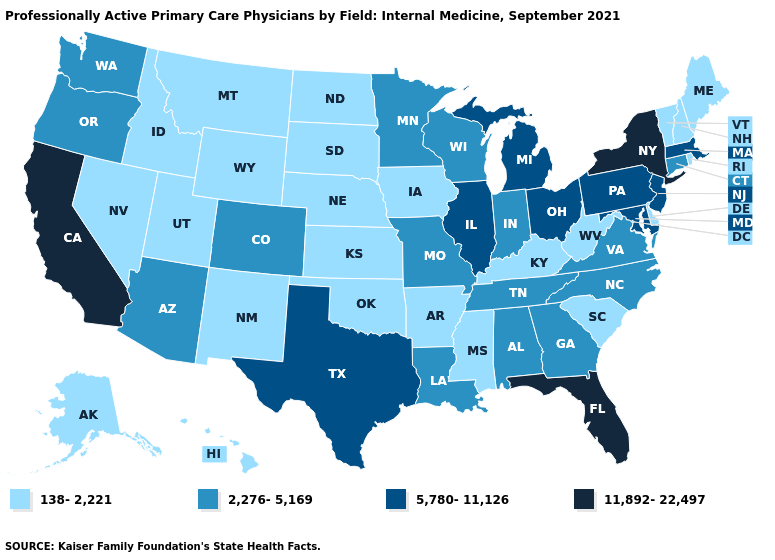Name the states that have a value in the range 5,780-11,126?
Concise answer only. Illinois, Maryland, Massachusetts, Michigan, New Jersey, Ohio, Pennsylvania, Texas. What is the value of Arkansas?
Concise answer only. 138-2,221. What is the value of Connecticut?
Write a very short answer. 2,276-5,169. What is the value of Massachusetts?
Answer briefly. 5,780-11,126. Does Kentucky have the lowest value in the South?
Concise answer only. Yes. How many symbols are there in the legend?
Keep it brief. 4. Name the states that have a value in the range 5,780-11,126?
Answer briefly. Illinois, Maryland, Massachusetts, Michigan, New Jersey, Ohio, Pennsylvania, Texas. What is the lowest value in the South?
Keep it brief. 138-2,221. Name the states that have a value in the range 138-2,221?
Answer briefly. Alaska, Arkansas, Delaware, Hawaii, Idaho, Iowa, Kansas, Kentucky, Maine, Mississippi, Montana, Nebraska, Nevada, New Hampshire, New Mexico, North Dakota, Oklahoma, Rhode Island, South Carolina, South Dakota, Utah, Vermont, West Virginia, Wyoming. What is the value of Vermont?
Give a very brief answer. 138-2,221. Which states hav the highest value in the West?
Keep it brief. California. What is the value of Minnesota?
Short answer required. 2,276-5,169. Which states hav the highest value in the MidWest?
Write a very short answer. Illinois, Michigan, Ohio. Name the states that have a value in the range 2,276-5,169?
Be succinct. Alabama, Arizona, Colorado, Connecticut, Georgia, Indiana, Louisiana, Minnesota, Missouri, North Carolina, Oregon, Tennessee, Virginia, Washington, Wisconsin. Does Illinois have a lower value than California?
Write a very short answer. Yes. 